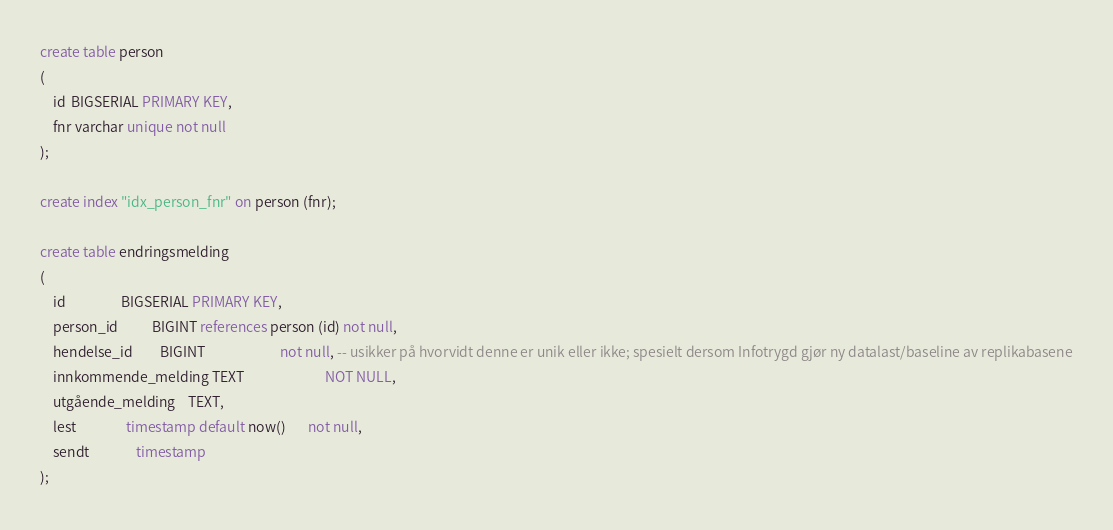<code> <loc_0><loc_0><loc_500><loc_500><_SQL_>create table person
(
    id  BIGSERIAL PRIMARY KEY,
    fnr varchar unique not null
);

create index "idx_person_fnr" on person (fnr);

create table endringsmelding
(
    id                  BIGSERIAL PRIMARY KEY,
    person_id           BIGINT references person (id) not null,
    hendelse_id         BIGINT                        not null, -- usikker på hvorvidt denne er unik eller ikke; spesielt dersom Infotrygd gjør ny datalast/baseline av replikabasene
    innkommende_melding TEXT                          NOT NULL,
    utgående_melding    TEXT,
    lest                timestamp default now()       not null,
    sendt               timestamp
);
</code> 